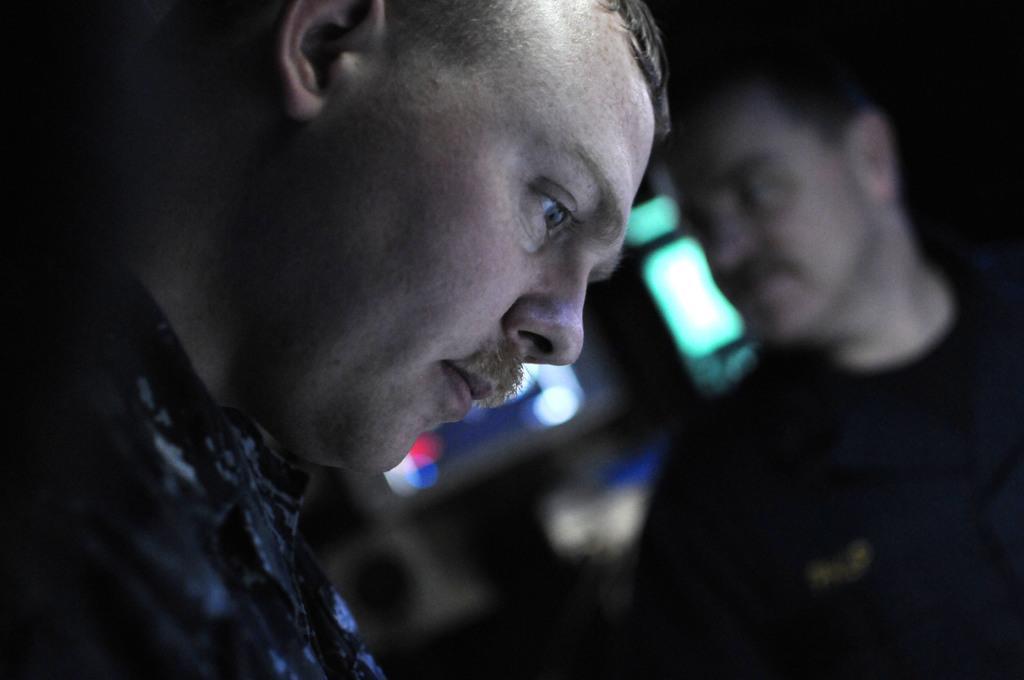Could you give a brief overview of what you see in this image? In this image, we can see a man. On the right side of the image, there is another man. On the right side and background, there is a blur view. 